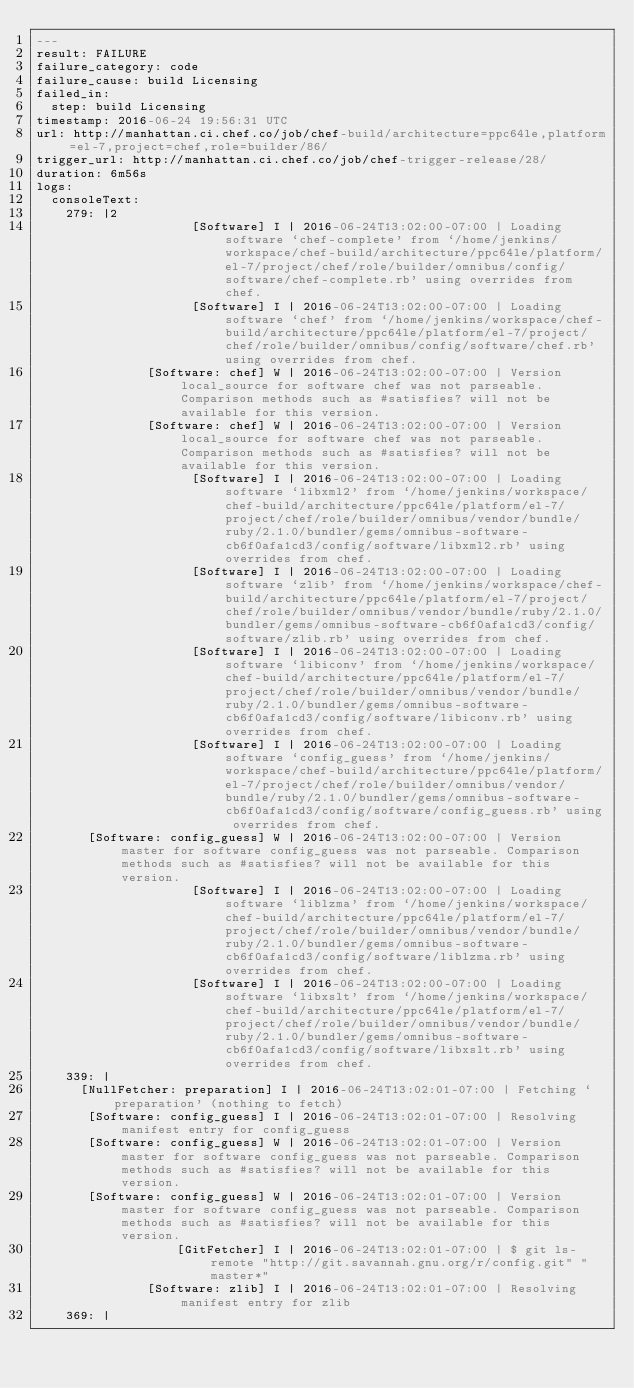Convert code to text. <code><loc_0><loc_0><loc_500><loc_500><_YAML_>---
result: FAILURE
failure_category: code
failure_cause: build Licensing
failed_in:
  step: build Licensing
timestamp: 2016-06-24 19:56:31 UTC
url: http://manhattan.ci.chef.co/job/chef-build/architecture=ppc64le,platform=el-7,project=chef,role=builder/86/
trigger_url: http://manhattan.ci.chef.co/job/chef-trigger-release/28/
duration: 6m56s
logs:
  consoleText:
    279: |2
                     [Software] I | 2016-06-24T13:02:00-07:00 | Loading software `chef-complete' from `/home/jenkins/workspace/chef-build/architecture/ppc64le/platform/el-7/project/chef/role/builder/omnibus/config/software/chef-complete.rb' using overrides from chef.
                     [Software] I | 2016-06-24T13:02:00-07:00 | Loading software `chef' from `/home/jenkins/workspace/chef-build/architecture/ppc64le/platform/el-7/project/chef/role/builder/omnibus/config/software/chef.rb' using overrides from chef.
               [Software: chef] W | 2016-06-24T13:02:00-07:00 | Version local_source for software chef was not parseable. Comparison methods such as #satisfies? will not be available for this version.
               [Software: chef] W | 2016-06-24T13:02:00-07:00 | Version local_source for software chef was not parseable. Comparison methods such as #satisfies? will not be available for this version.
                     [Software] I | 2016-06-24T13:02:00-07:00 | Loading software `libxml2' from `/home/jenkins/workspace/chef-build/architecture/ppc64le/platform/el-7/project/chef/role/builder/omnibus/vendor/bundle/ruby/2.1.0/bundler/gems/omnibus-software-cb6f0afa1cd3/config/software/libxml2.rb' using overrides from chef.
                     [Software] I | 2016-06-24T13:02:00-07:00 | Loading software `zlib' from `/home/jenkins/workspace/chef-build/architecture/ppc64le/platform/el-7/project/chef/role/builder/omnibus/vendor/bundle/ruby/2.1.0/bundler/gems/omnibus-software-cb6f0afa1cd3/config/software/zlib.rb' using overrides from chef.
                     [Software] I | 2016-06-24T13:02:00-07:00 | Loading software `libiconv' from `/home/jenkins/workspace/chef-build/architecture/ppc64le/platform/el-7/project/chef/role/builder/omnibus/vendor/bundle/ruby/2.1.0/bundler/gems/omnibus-software-cb6f0afa1cd3/config/software/libiconv.rb' using overrides from chef.
                     [Software] I | 2016-06-24T13:02:00-07:00 | Loading software `config_guess' from `/home/jenkins/workspace/chef-build/architecture/ppc64le/platform/el-7/project/chef/role/builder/omnibus/vendor/bundle/ruby/2.1.0/bundler/gems/omnibus-software-cb6f0afa1cd3/config/software/config_guess.rb' using overrides from chef.
       [Software: config_guess] W | 2016-06-24T13:02:00-07:00 | Version master for software config_guess was not parseable. Comparison methods such as #satisfies? will not be available for this version.
                     [Software] I | 2016-06-24T13:02:00-07:00 | Loading software `liblzma' from `/home/jenkins/workspace/chef-build/architecture/ppc64le/platform/el-7/project/chef/role/builder/omnibus/vendor/bundle/ruby/2.1.0/bundler/gems/omnibus-software-cb6f0afa1cd3/config/software/liblzma.rb' using overrides from chef.
                     [Software] I | 2016-06-24T13:02:00-07:00 | Loading software `libxslt' from `/home/jenkins/workspace/chef-build/architecture/ppc64le/platform/el-7/project/chef/role/builder/omnibus/vendor/bundle/ruby/2.1.0/bundler/gems/omnibus-software-cb6f0afa1cd3/config/software/libxslt.rb' using overrides from chef.
    339: |
      [NullFetcher: preparation] I | 2016-06-24T13:02:01-07:00 | Fetching `preparation' (nothing to fetch)
       [Software: config_guess] I | 2016-06-24T13:02:01-07:00 | Resolving manifest entry for config_guess
       [Software: config_guess] W | 2016-06-24T13:02:01-07:00 | Version master for software config_guess was not parseable. Comparison methods such as #satisfies? will not be available for this version.
       [Software: config_guess] W | 2016-06-24T13:02:01-07:00 | Version master for software config_guess was not parseable. Comparison methods such as #satisfies? will not be available for this version.
                   [GitFetcher] I | 2016-06-24T13:02:01-07:00 | $ git ls-remote "http://git.savannah.gnu.org/r/config.git" "master*"
               [Software: zlib] I | 2016-06-24T13:02:01-07:00 | Resolving manifest entry for zlib
    369: |</code> 